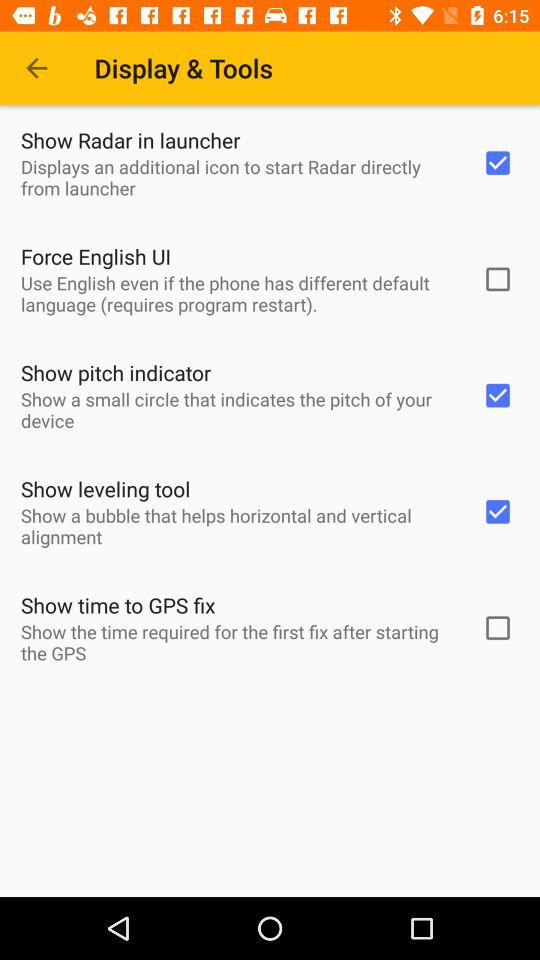Which language will be used even if the phone has different default language?
When the provided information is insufficient, respond with <no answer>. <no answer> 